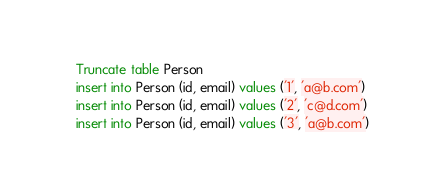Convert code to text. <code><loc_0><loc_0><loc_500><loc_500><_SQL_>Truncate table Person
insert into Person (id, email) values ('1', 'a@b.com')
insert into Person (id, email) values ('2', 'c@d.com')
insert into Person (id, email) values ('3', 'a@b.com')
</code> 